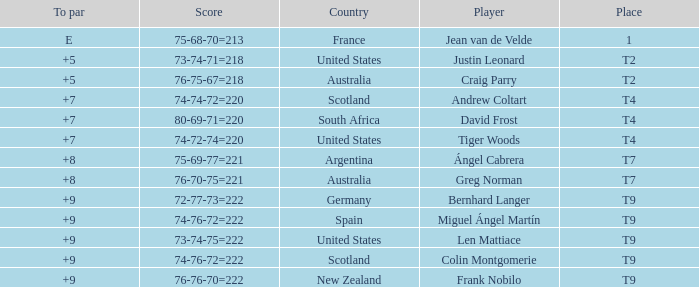For the match in which player David Frost scored a To Par of +7, what was the final score? 80-69-71=220. 